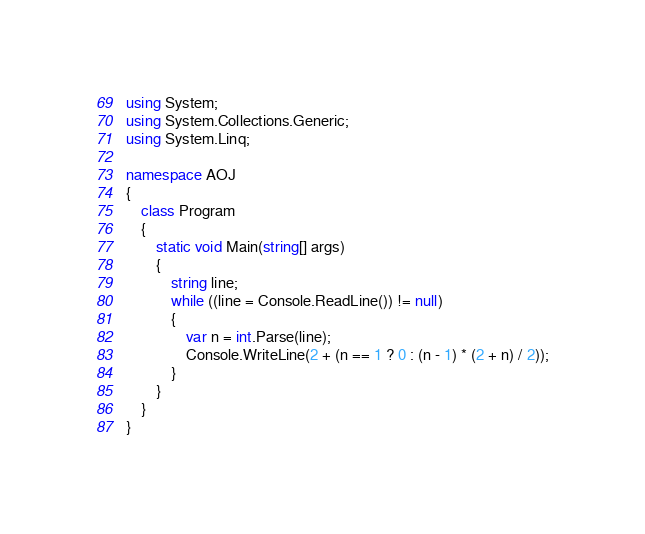Convert code to text. <code><loc_0><loc_0><loc_500><loc_500><_C#_>using System;
using System.Collections.Generic;
using System.Linq;

namespace AOJ
{
    class Program
    {
        static void Main(string[] args)
        {
            string line;
            while ((line = Console.ReadLine()) != null)
            {
                var n = int.Parse(line);
                Console.WriteLine(2 + (n == 1 ? 0 : (n - 1) * (2 + n) / 2));
            }
        }
    }
}</code> 